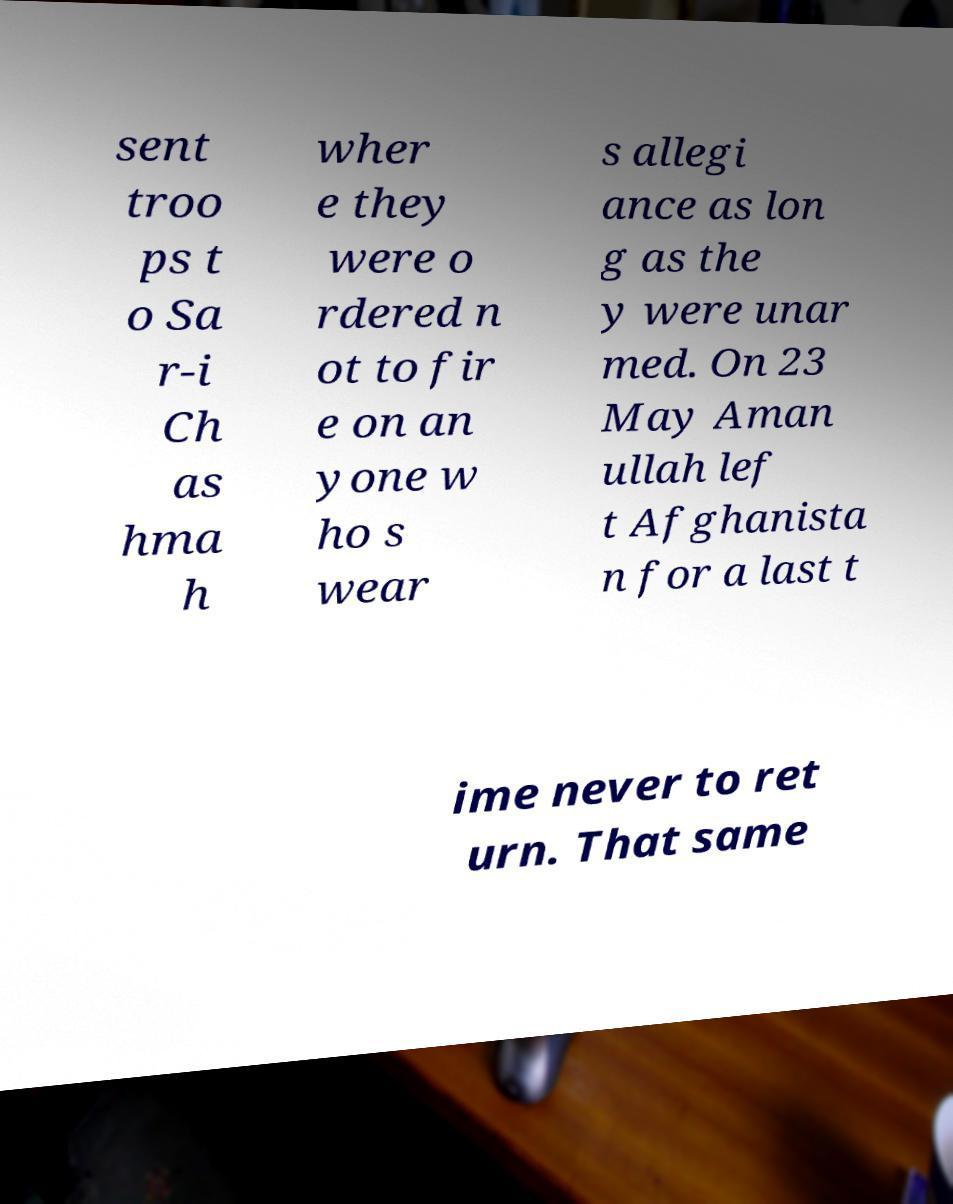Could you extract and type out the text from this image? sent troo ps t o Sa r-i Ch as hma h wher e they were o rdered n ot to fir e on an yone w ho s wear s allegi ance as lon g as the y were unar med. On 23 May Aman ullah lef t Afghanista n for a last t ime never to ret urn. That same 